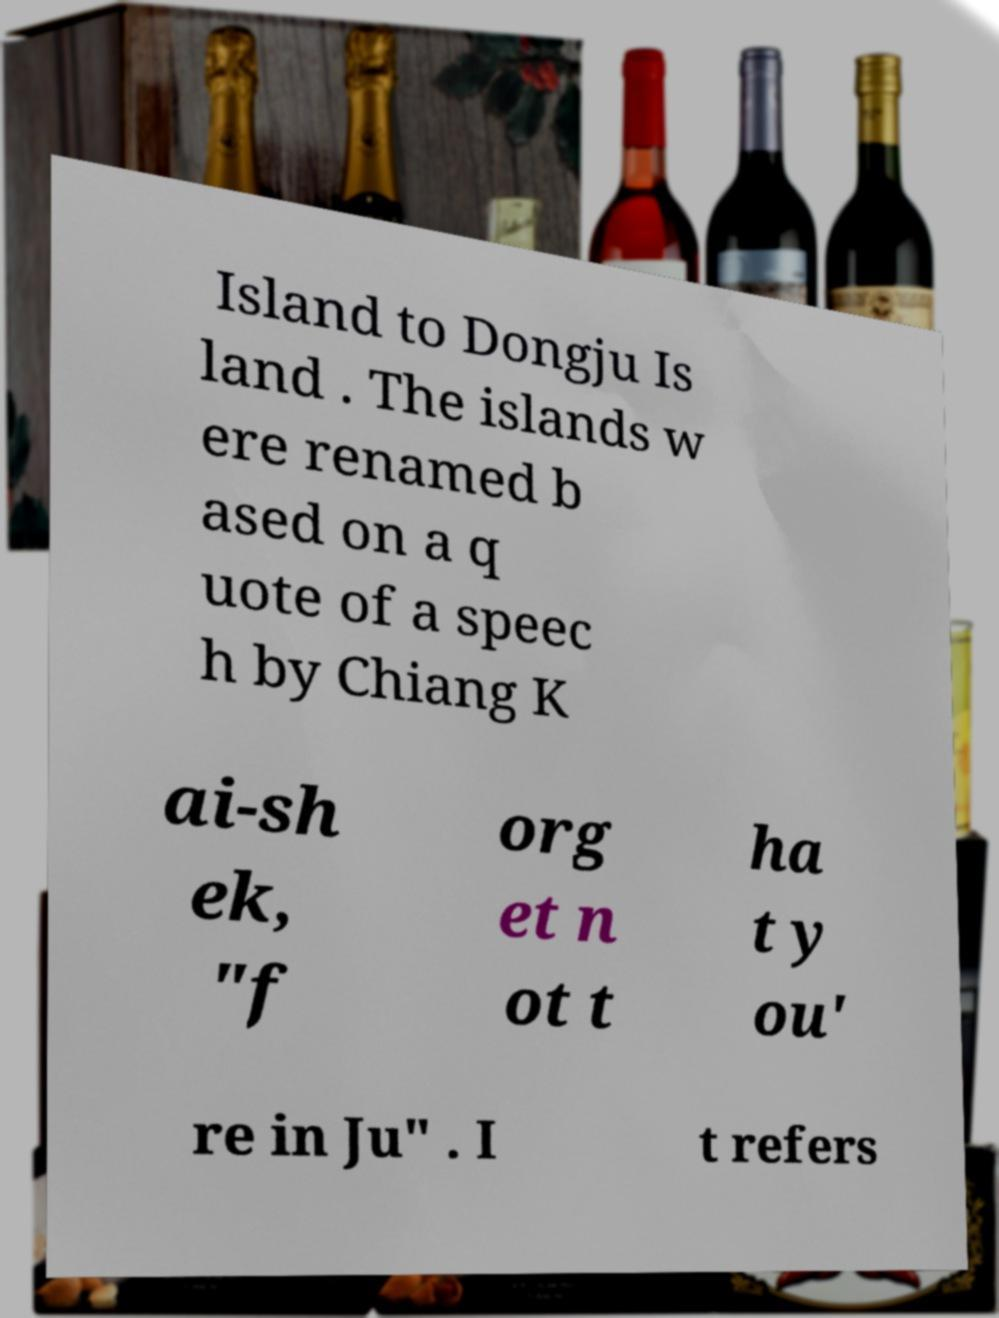There's text embedded in this image that I need extracted. Can you transcribe it verbatim? Island to Dongju Is land . The islands w ere renamed b ased on a q uote of a speec h by Chiang K ai-sh ek, "f org et n ot t ha t y ou' re in Ju" . I t refers 